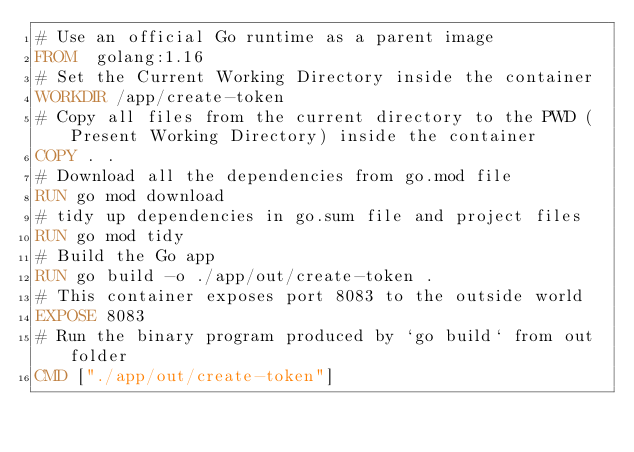Convert code to text. <code><loc_0><loc_0><loc_500><loc_500><_Dockerfile_># Use an official Go runtime as a parent image
FROM  golang:1.16
# Set the Current Working Directory inside the container
WORKDIR /app/create-token
# Copy all files from the current directory to the PWD (Present Working Directory) inside the container
COPY . .
# Download all the dependencies from go.mod file
RUN go mod download
# tidy up dependencies in go.sum file and project files
RUN go mod tidy
# Build the Go app
RUN go build -o ./app/out/create-token .
# This container exposes port 8083 to the outside world
EXPOSE 8083
# Run the binary program produced by `go build` from out folder
CMD ["./app/out/create-token"]</code> 